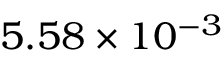Convert formula to latex. <formula><loc_0><loc_0><loc_500><loc_500>5 . 5 8 \times 1 0 ^ { - 3 }</formula> 